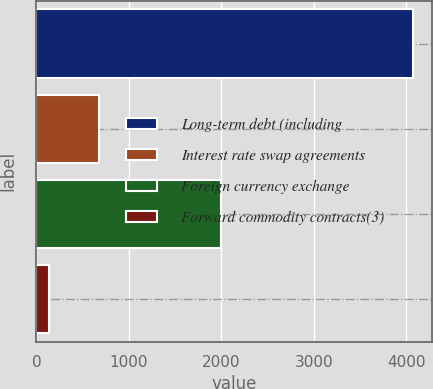Convert chart. <chart><loc_0><loc_0><loc_500><loc_500><bar_chart><fcel>Long-term debt (including<fcel>Interest rate swap agreements<fcel>Foreign currency exchange<fcel>Forward commodity contracts(3)<nl><fcel>4070<fcel>681<fcel>1998<fcel>141<nl></chart> 